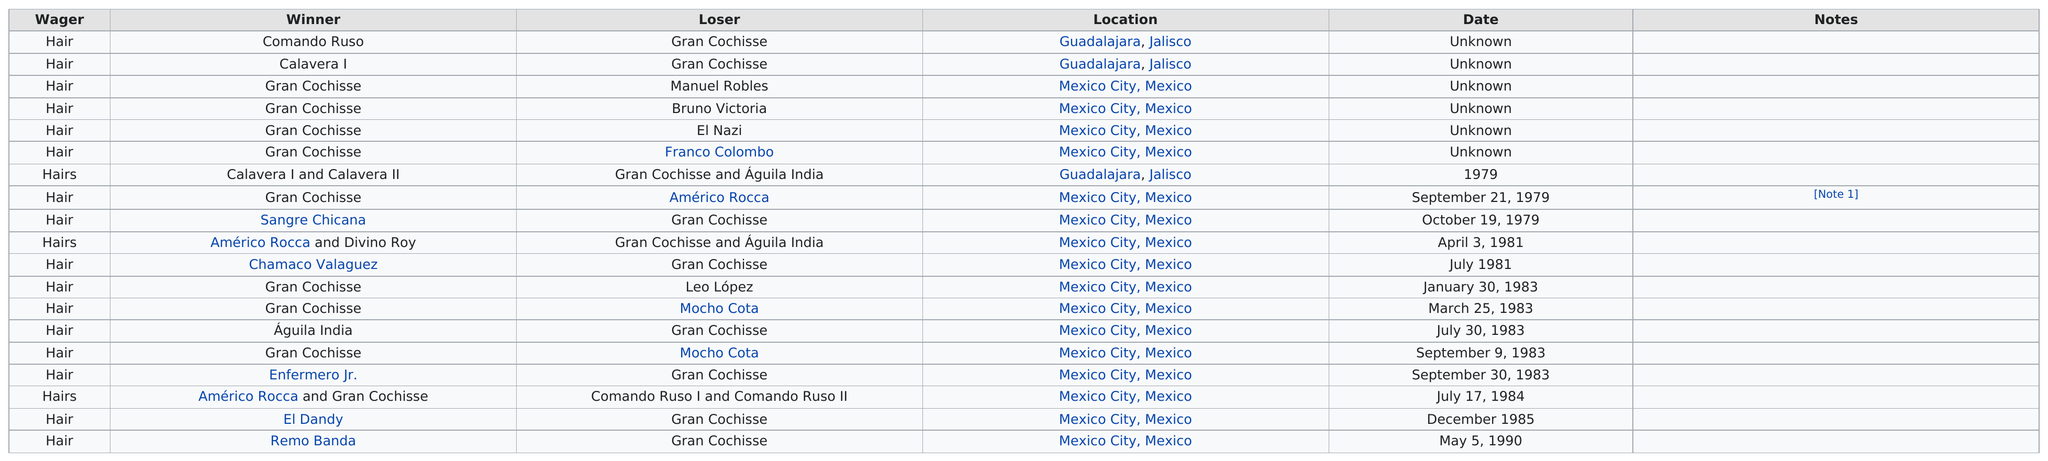Identify some key points in this picture. Gran Cochisse suffered one loss against El Dandy. There were 3 winners before Bruno Victoria lost. On September 21, 1979, the first recorded match featuring Gran Chochisse took place. Sangre Chicana won more games than Chamaco Valaguez. The wager has been placed 16 times. 